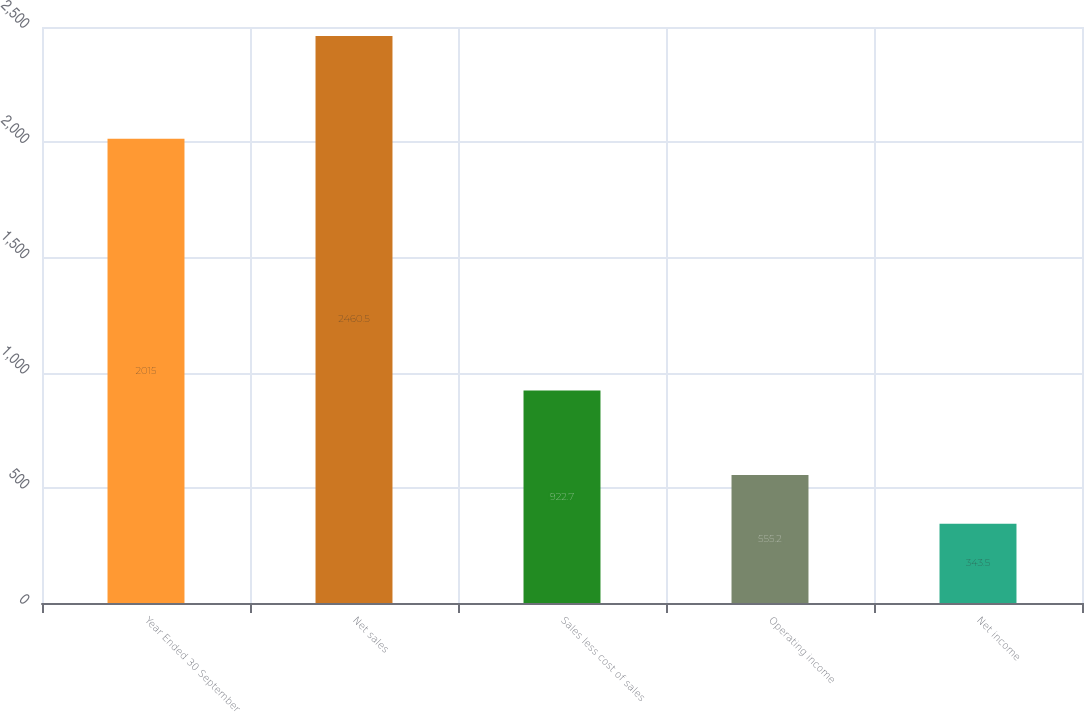<chart> <loc_0><loc_0><loc_500><loc_500><bar_chart><fcel>Year Ended 30 September<fcel>Net sales<fcel>Sales less cost of sales<fcel>Operating income<fcel>Net income<nl><fcel>2015<fcel>2460.5<fcel>922.7<fcel>555.2<fcel>343.5<nl></chart> 